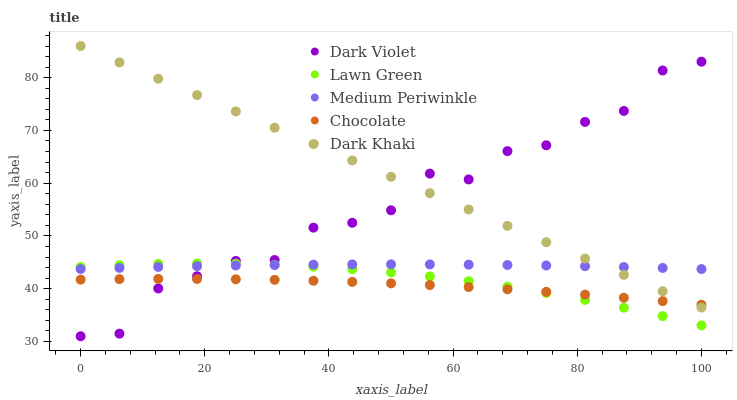Does Chocolate have the minimum area under the curve?
Answer yes or no. Yes. Does Dark Khaki have the maximum area under the curve?
Answer yes or no. Yes. Does Lawn Green have the minimum area under the curve?
Answer yes or no. No. Does Lawn Green have the maximum area under the curve?
Answer yes or no. No. Is Dark Khaki the smoothest?
Answer yes or no. Yes. Is Dark Violet the roughest?
Answer yes or no. Yes. Is Lawn Green the smoothest?
Answer yes or no. No. Is Lawn Green the roughest?
Answer yes or no. No. Does Dark Violet have the lowest value?
Answer yes or no. Yes. Does Lawn Green have the lowest value?
Answer yes or no. No. Does Dark Khaki have the highest value?
Answer yes or no. Yes. Does Lawn Green have the highest value?
Answer yes or no. No. Is Chocolate less than Medium Periwinkle?
Answer yes or no. Yes. Is Dark Khaki greater than Lawn Green?
Answer yes or no. Yes. Does Medium Periwinkle intersect Dark Khaki?
Answer yes or no. Yes. Is Medium Periwinkle less than Dark Khaki?
Answer yes or no. No. Is Medium Periwinkle greater than Dark Khaki?
Answer yes or no. No. Does Chocolate intersect Medium Periwinkle?
Answer yes or no. No. 